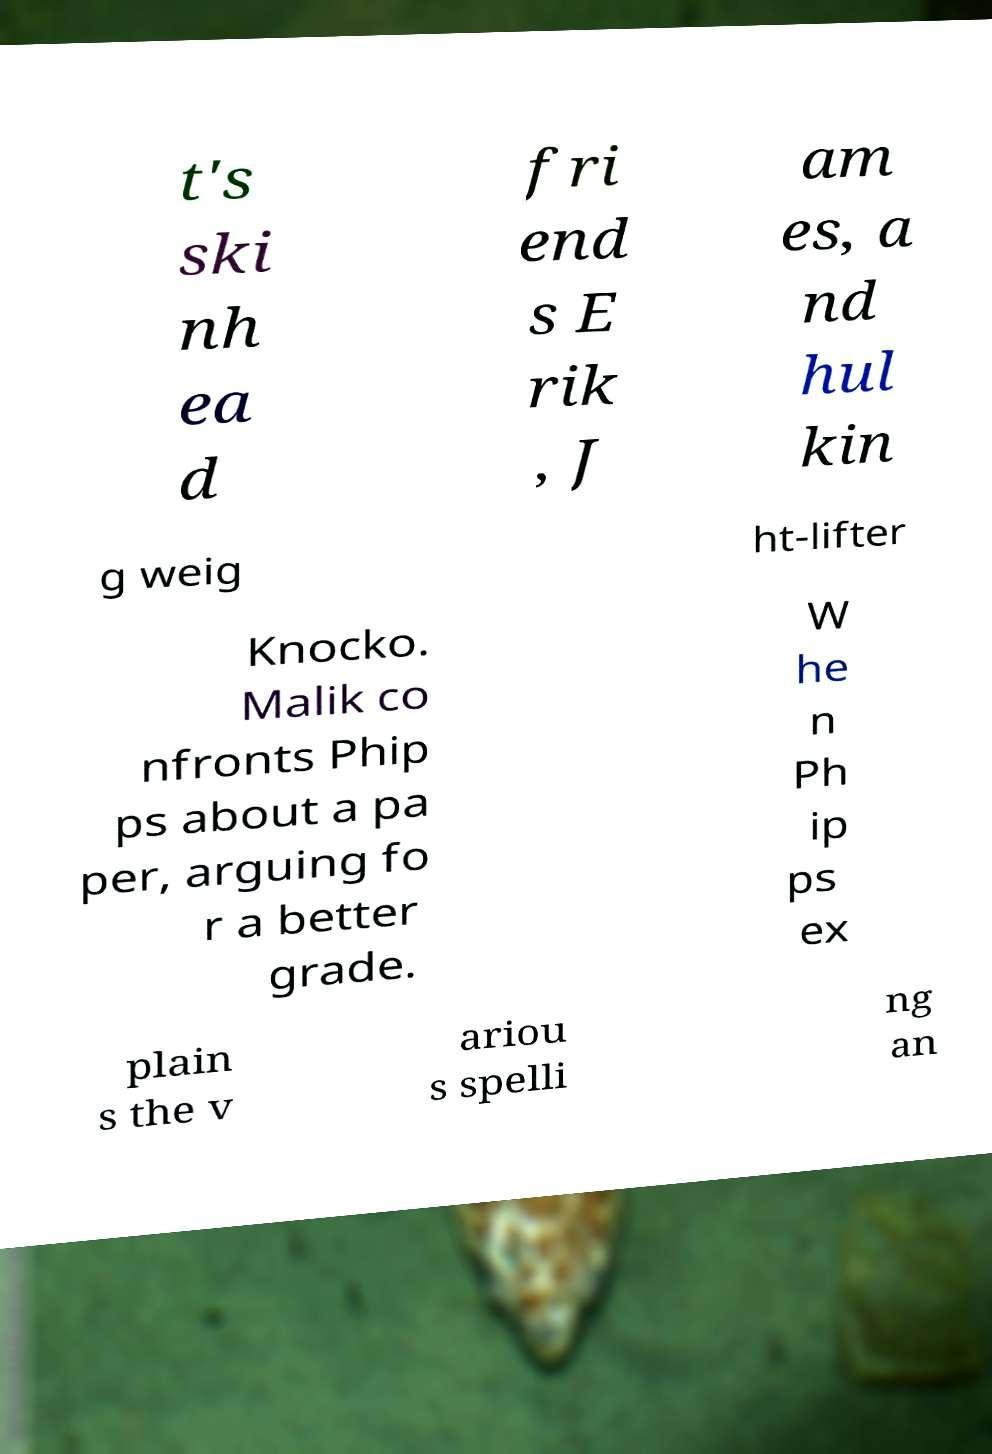Can you read and provide the text displayed in the image?This photo seems to have some interesting text. Can you extract and type it out for me? t's ski nh ea d fri end s E rik , J am es, a nd hul kin g weig ht-lifter Knocko. Malik co nfronts Phip ps about a pa per, arguing fo r a better grade. W he n Ph ip ps ex plain s the v ariou s spelli ng an 